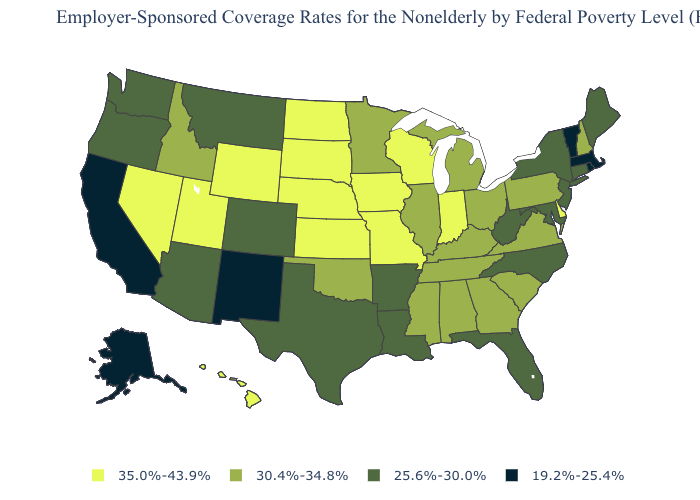What is the highest value in the USA?
Keep it brief. 35.0%-43.9%. What is the highest value in the West ?
Concise answer only. 35.0%-43.9%. Among the states that border Oregon , does California have the highest value?
Concise answer only. No. Is the legend a continuous bar?
Short answer required. No. Does New Jersey have a higher value than Hawaii?
Concise answer only. No. Does Alabama have the lowest value in the USA?
Answer briefly. No. Does Washington have the lowest value in the West?
Answer briefly. No. Does Michigan have the highest value in the MidWest?
Quick response, please. No. Name the states that have a value in the range 30.4%-34.8%?
Quick response, please. Alabama, Georgia, Idaho, Illinois, Kentucky, Michigan, Minnesota, Mississippi, New Hampshire, Ohio, Oklahoma, Pennsylvania, South Carolina, Tennessee, Virginia. Which states have the lowest value in the USA?
Answer briefly. Alaska, California, Massachusetts, New Mexico, Rhode Island, Vermont. Does the first symbol in the legend represent the smallest category?
Write a very short answer. No. Among the states that border Alabama , which have the lowest value?
Be succinct. Florida. What is the lowest value in the USA?
Be succinct. 19.2%-25.4%. What is the highest value in the USA?
Short answer required. 35.0%-43.9%. Among the states that border Maine , which have the highest value?
Short answer required. New Hampshire. 